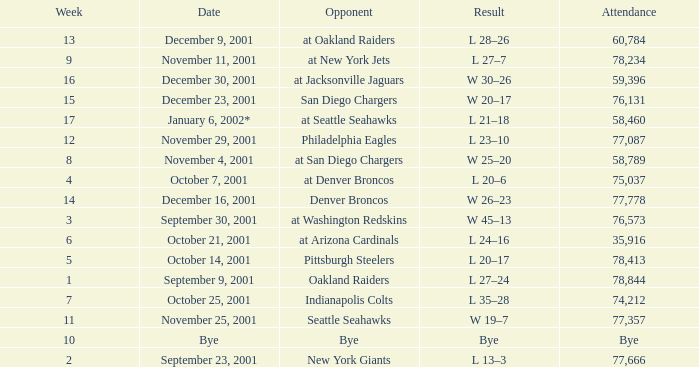What week is a bye week? 10.0. 